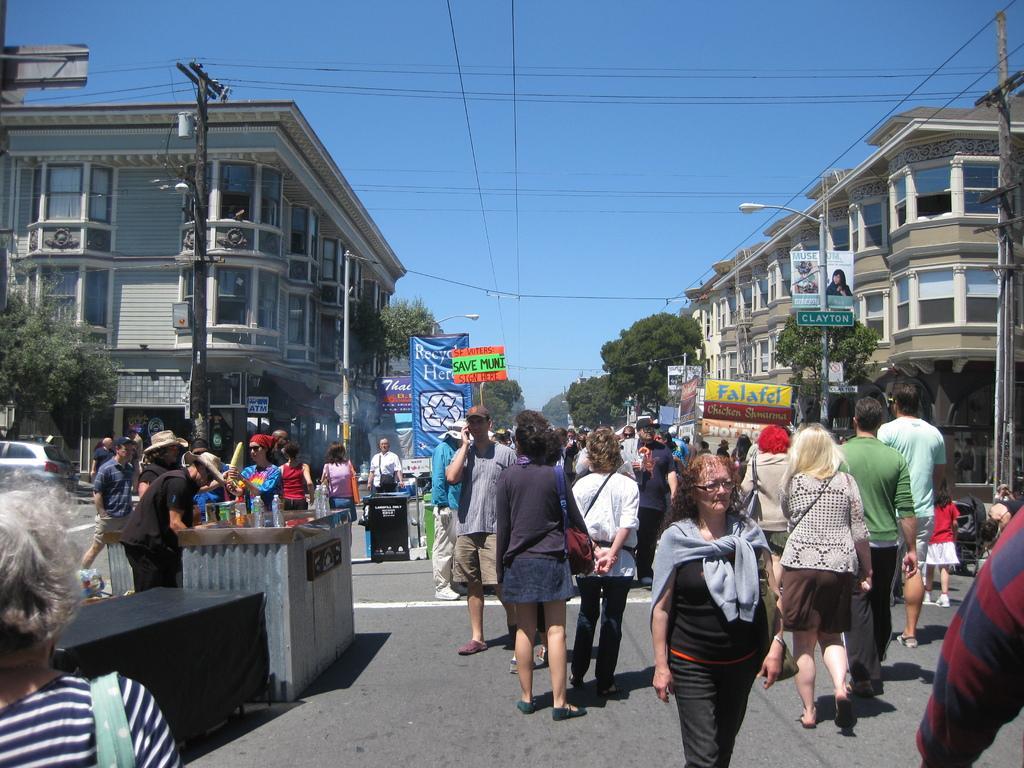Describe this image in one or two sentences. In the picture we can see a street with a road on it, we can see people are walking and some are standing on the path near the road and on the either sides of the road we can see buildings with windows and poles with street lights and some poles with electric lights and in the background we can see trees and sky. 